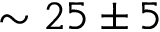<formula> <loc_0><loc_0><loc_500><loc_500>\sim 2 5 \pm 5</formula> 